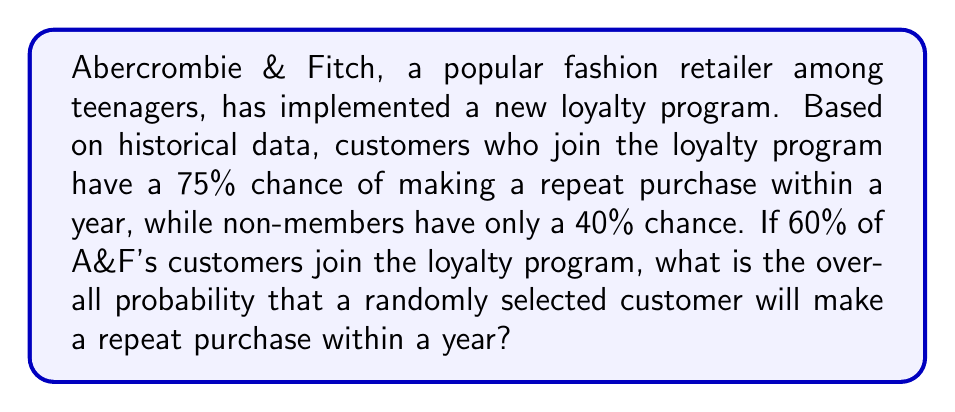Teach me how to tackle this problem. Let's approach this step-by-step:

1) First, let's define our events:
   A: Customer joins the loyalty program
   B: Customer makes a repeat purchase within a year

2) We're given the following probabilities:
   $P(A) = 0.60$ (60% of customers join the program)
   $P(B|A) = 0.75$ (75% chance of repeat purchase for program members)
   $P(B|\text{not }A) = 0.40$ (40% chance of repeat purchase for non-members)

3) We want to find $P(B)$, the overall probability of a repeat purchase.

4) We can use the law of total probability:
   
   $P(B) = P(B|A) \cdot P(A) + P(B|\text{not }A) \cdot P(\text{not }A)$

5) We know $P(A) = 0.60$, so $P(\text{not }A) = 1 - P(A) = 0.40$

6) Now let's substitute all our values into the formula:

   $P(B) = 0.75 \cdot 0.60 + 0.40 \cdot 0.40$

7) Let's calculate:
   
   $P(B) = 0.45 + 0.16 = 0.61$

Therefore, the overall probability that a randomly selected customer will make a repeat purchase within a year is 0.61 or 61%.
Answer: 0.61 or 61% 